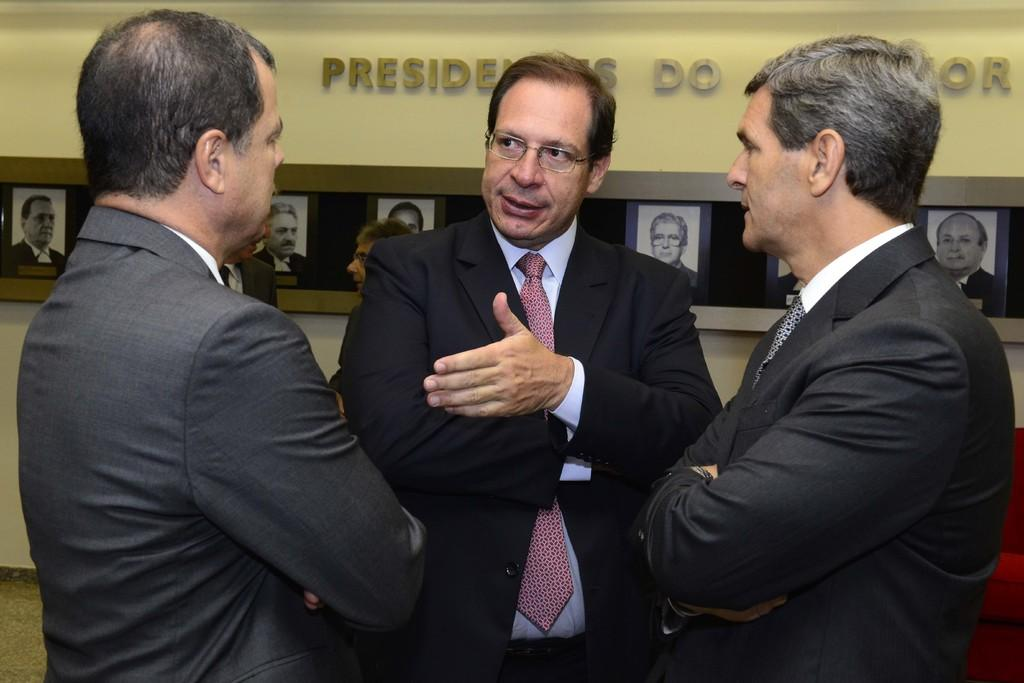How many people are in the image? There is a group of men standing in the image. What is the surface the men are standing on? The men are standing on the floor. What can be seen in the background of the image? There is a sofa and a wall visible in the background of the image. What is on the wall in the image? The wall has photo frames on it, and there is text visible on the wall. What type of haircut does the man in the middle have? There is no information about the men's haircuts in the image, so it cannot be determined. 